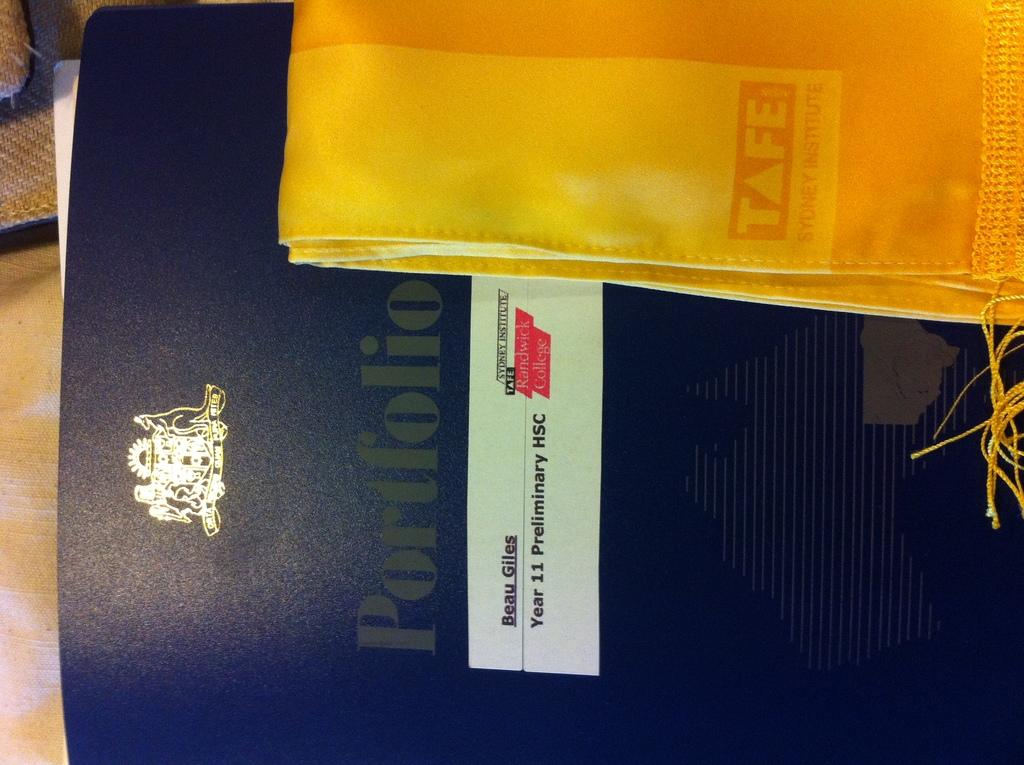Provide a one-sentence caption for the provided image. A folder about Beau Giles sits under a golden cloth. 